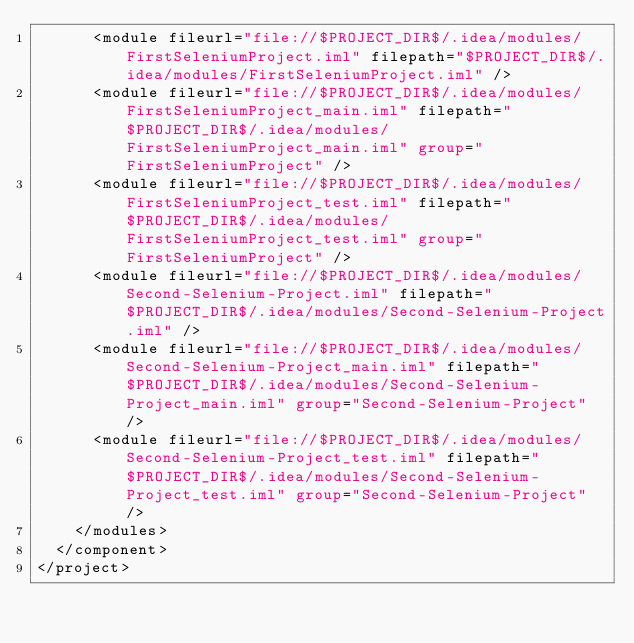<code> <loc_0><loc_0><loc_500><loc_500><_XML_>      <module fileurl="file://$PROJECT_DIR$/.idea/modules/FirstSeleniumProject.iml" filepath="$PROJECT_DIR$/.idea/modules/FirstSeleniumProject.iml" />
      <module fileurl="file://$PROJECT_DIR$/.idea/modules/FirstSeleniumProject_main.iml" filepath="$PROJECT_DIR$/.idea/modules/FirstSeleniumProject_main.iml" group="FirstSeleniumProject" />
      <module fileurl="file://$PROJECT_DIR$/.idea/modules/FirstSeleniumProject_test.iml" filepath="$PROJECT_DIR$/.idea/modules/FirstSeleniumProject_test.iml" group="FirstSeleniumProject" />
      <module fileurl="file://$PROJECT_DIR$/.idea/modules/Second-Selenium-Project.iml" filepath="$PROJECT_DIR$/.idea/modules/Second-Selenium-Project.iml" />
      <module fileurl="file://$PROJECT_DIR$/.idea/modules/Second-Selenium-Project_main.iml" filepath="$PROJECT_DIR$/.idea/modules/Second-Selenium-Project_main.iml" group="Second-Selenium-Project" />
      <module fileurl="file://$PROJECT_DIR$/.idea/modules/Second-Selenium-Project_test.iml" filepath="$PROJECT_DIR$/.idea/modules/Second-Selenium-Project_test.iml" group="Second-Selenium-Project" />
    </modules>
  </component>
</project></code> 